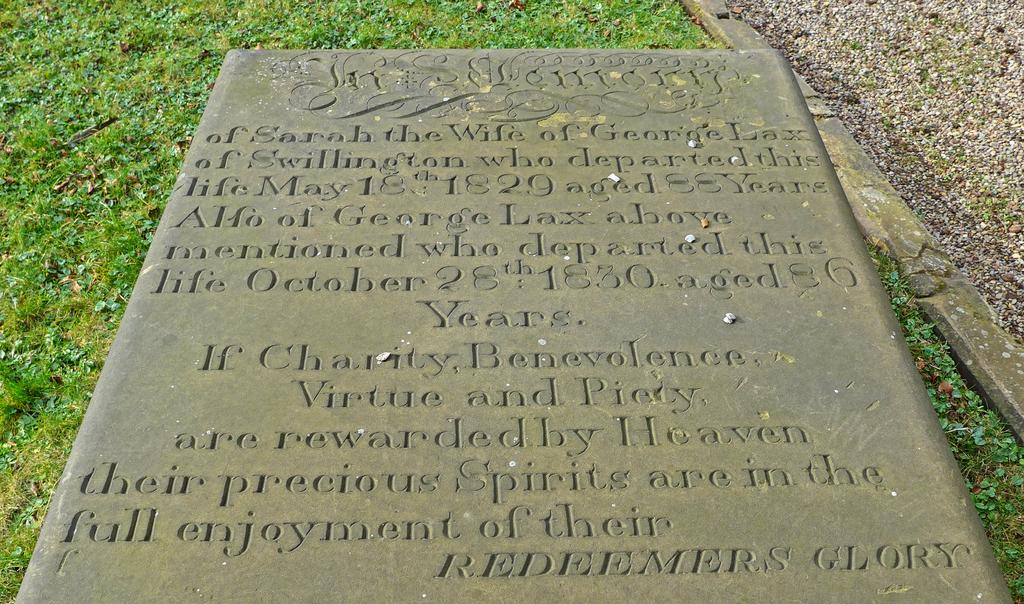What is the main subject of the image? There is a memorial in the image. What can be seen on the memorial? The memorial has some text on it. What type of natural environment is visible in the background of the image? There is grass visible in the background of the image. How many pizzas are stacked on top of each other in the image? There are no pizzas present in the image, so it is not possible to determine the number of pizzas stacked on top of each other. 